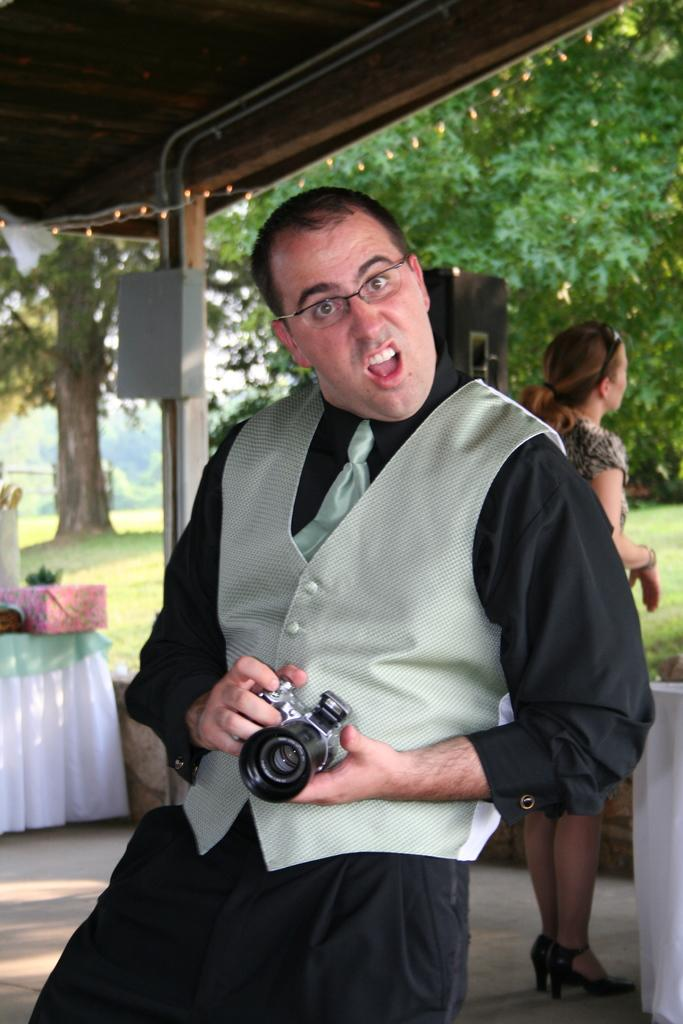What is the man in the middle of the image doing? The man is standing in the middle of the image and holding a camera. What is the man wearing in the image? The man is wearing a jacket and a tie. Who else is present in the image? There is a woman on the right side of the image. What type of lumber is being transported by the flame in the image? There is no lumber or flame present in the image. 